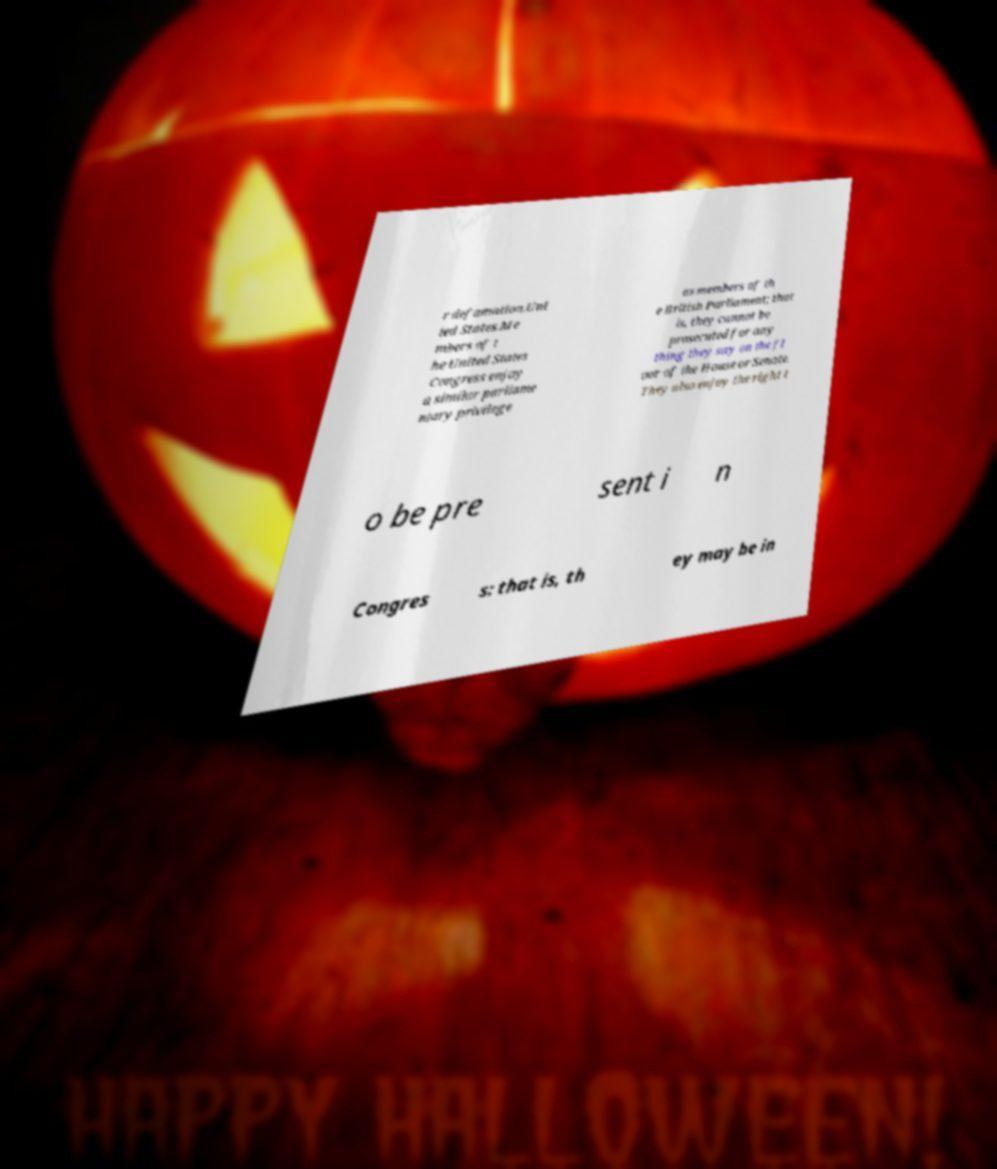I need the written content from this picture converted into text. Can you do that? r defamation.Uni ted States.Me mbers of t he United States Congress enjoy a similar parliame ntary privilege as members of th e British Parliament; that is, they cannot be prosecuted for any thing they say on the fl oor of the House or Senate. They also enjoy the right t o be pre sent i n Congres s: that is, th ey may be in 